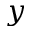<formula> <loc_0><loc_0><loc_500><loc_500>y</formula> 